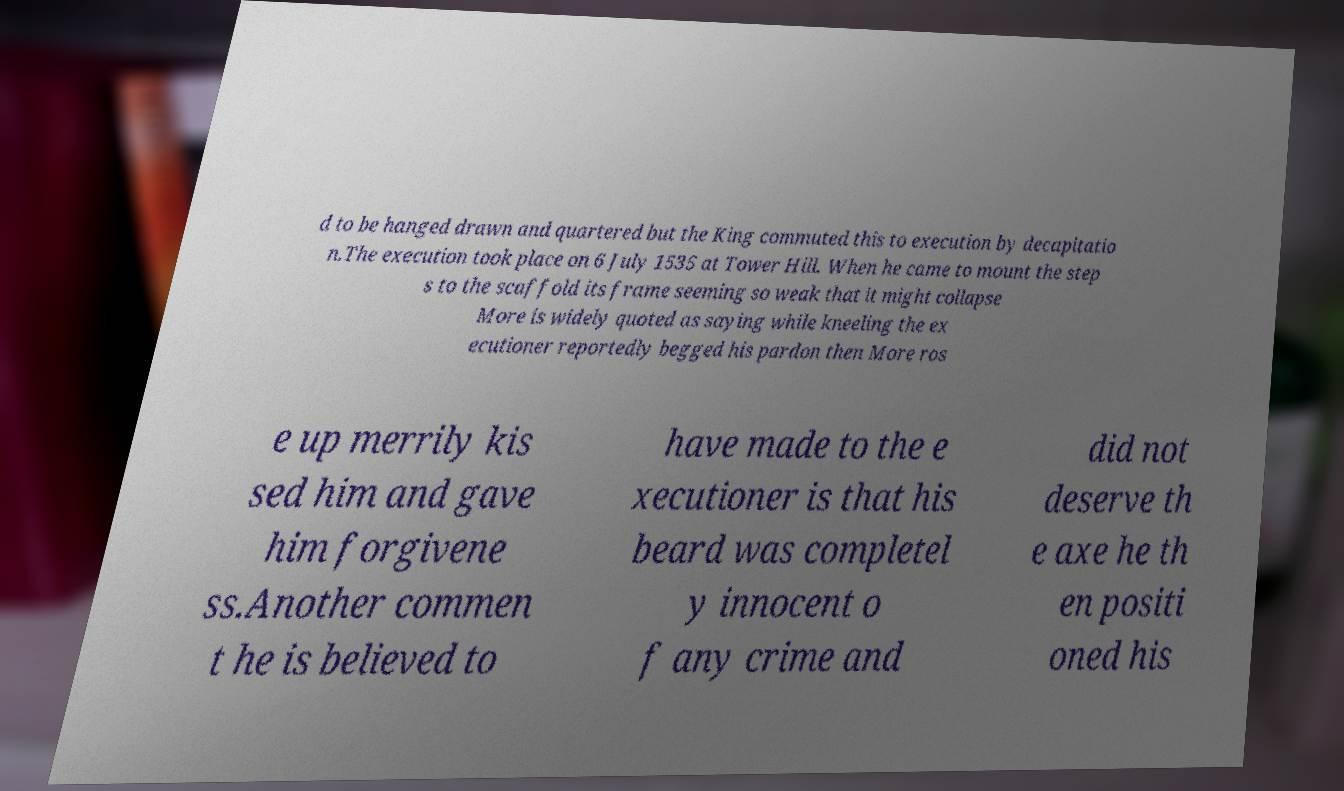Please read and relay the text visible in this image. What does it say? d to be hanged drawn and quartered but the King commuted this to execution by decapitatio n.The execution took place on 6 July 1535 at Tower Hill. When he came to mount the step s to the scaffold its frame seeming so weak that it might collapse More is widely quoted as saying while kneeling the ex ecutioner reportedly begged his pardon then More ros e up merrily kis sed him and gave him forgivene ss.Another commen t he is believed to have made to the e xecutioner is that his beard was completel y innocent o f any crime and did not deserve th e axe he th en positi oned his 